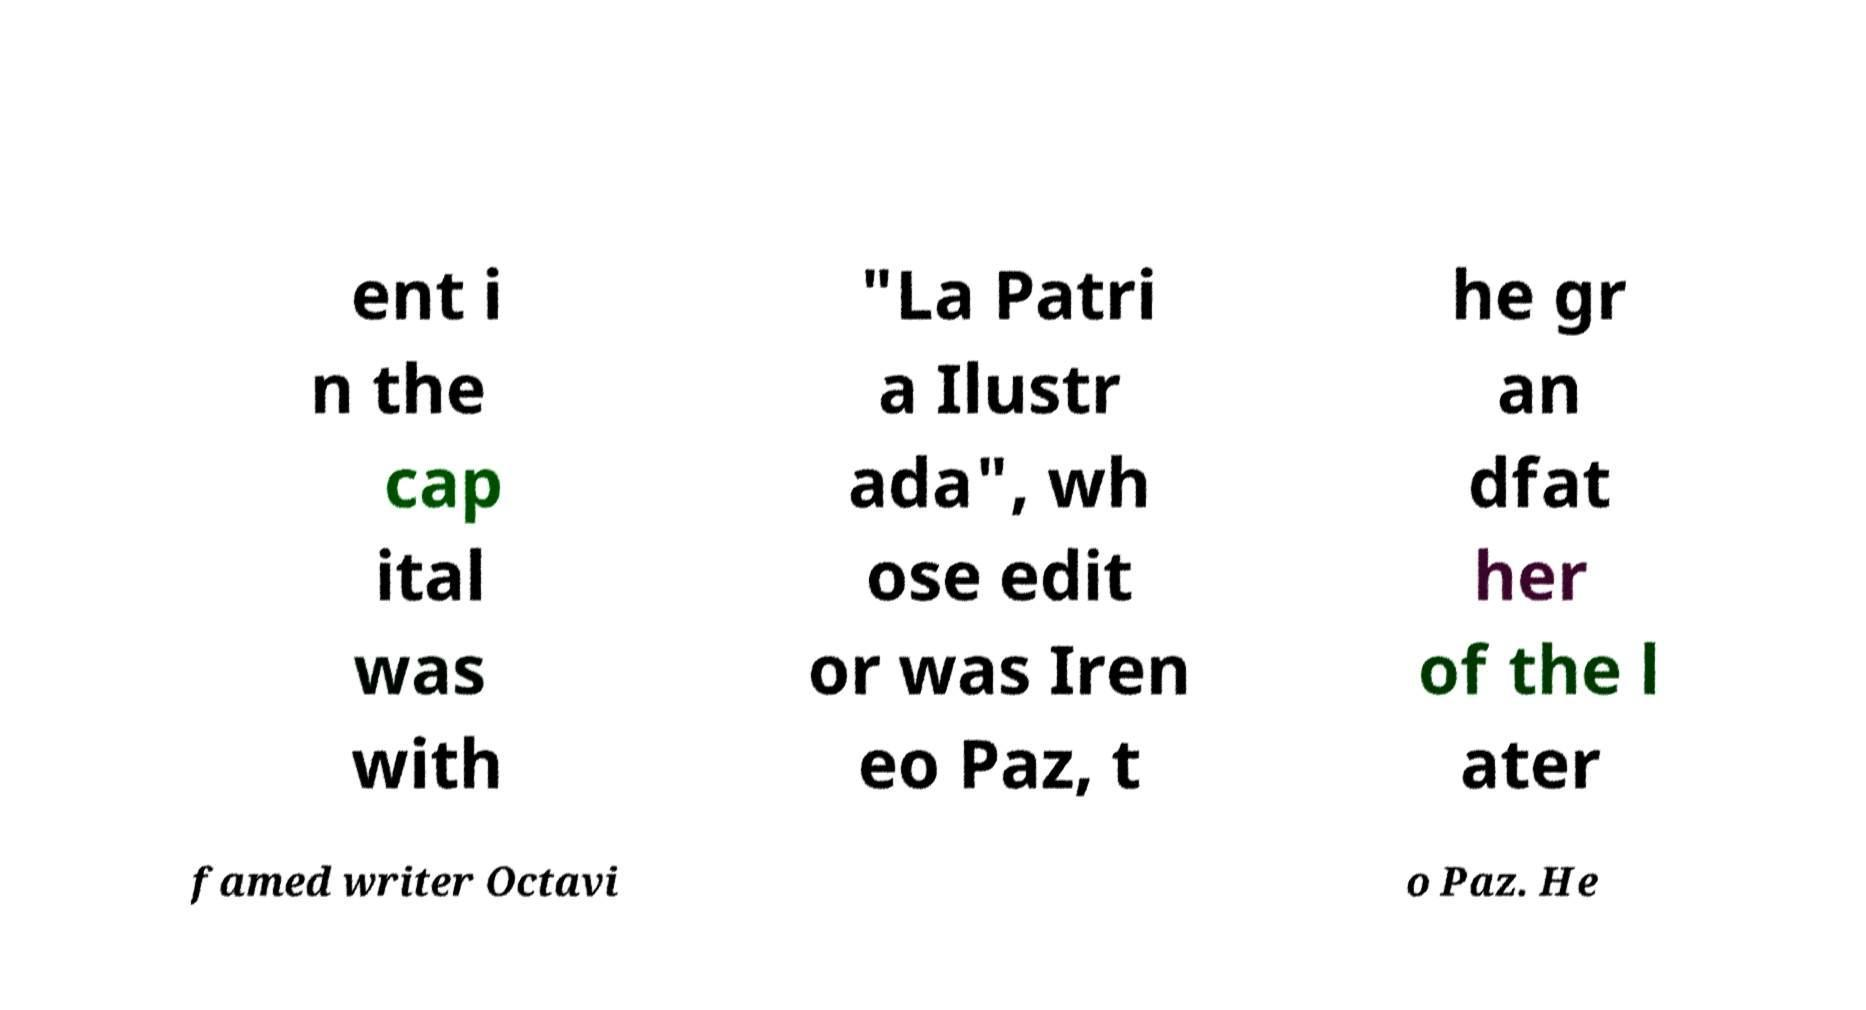Please read and relay the text visible in this image. What does it say? ent i n the cap ital was with "La Patri a Ilustr ada", wh ose edit or was Iren eo Paz, t he gr an dfat her of the l ater famed writer Octavi o Paz. He 